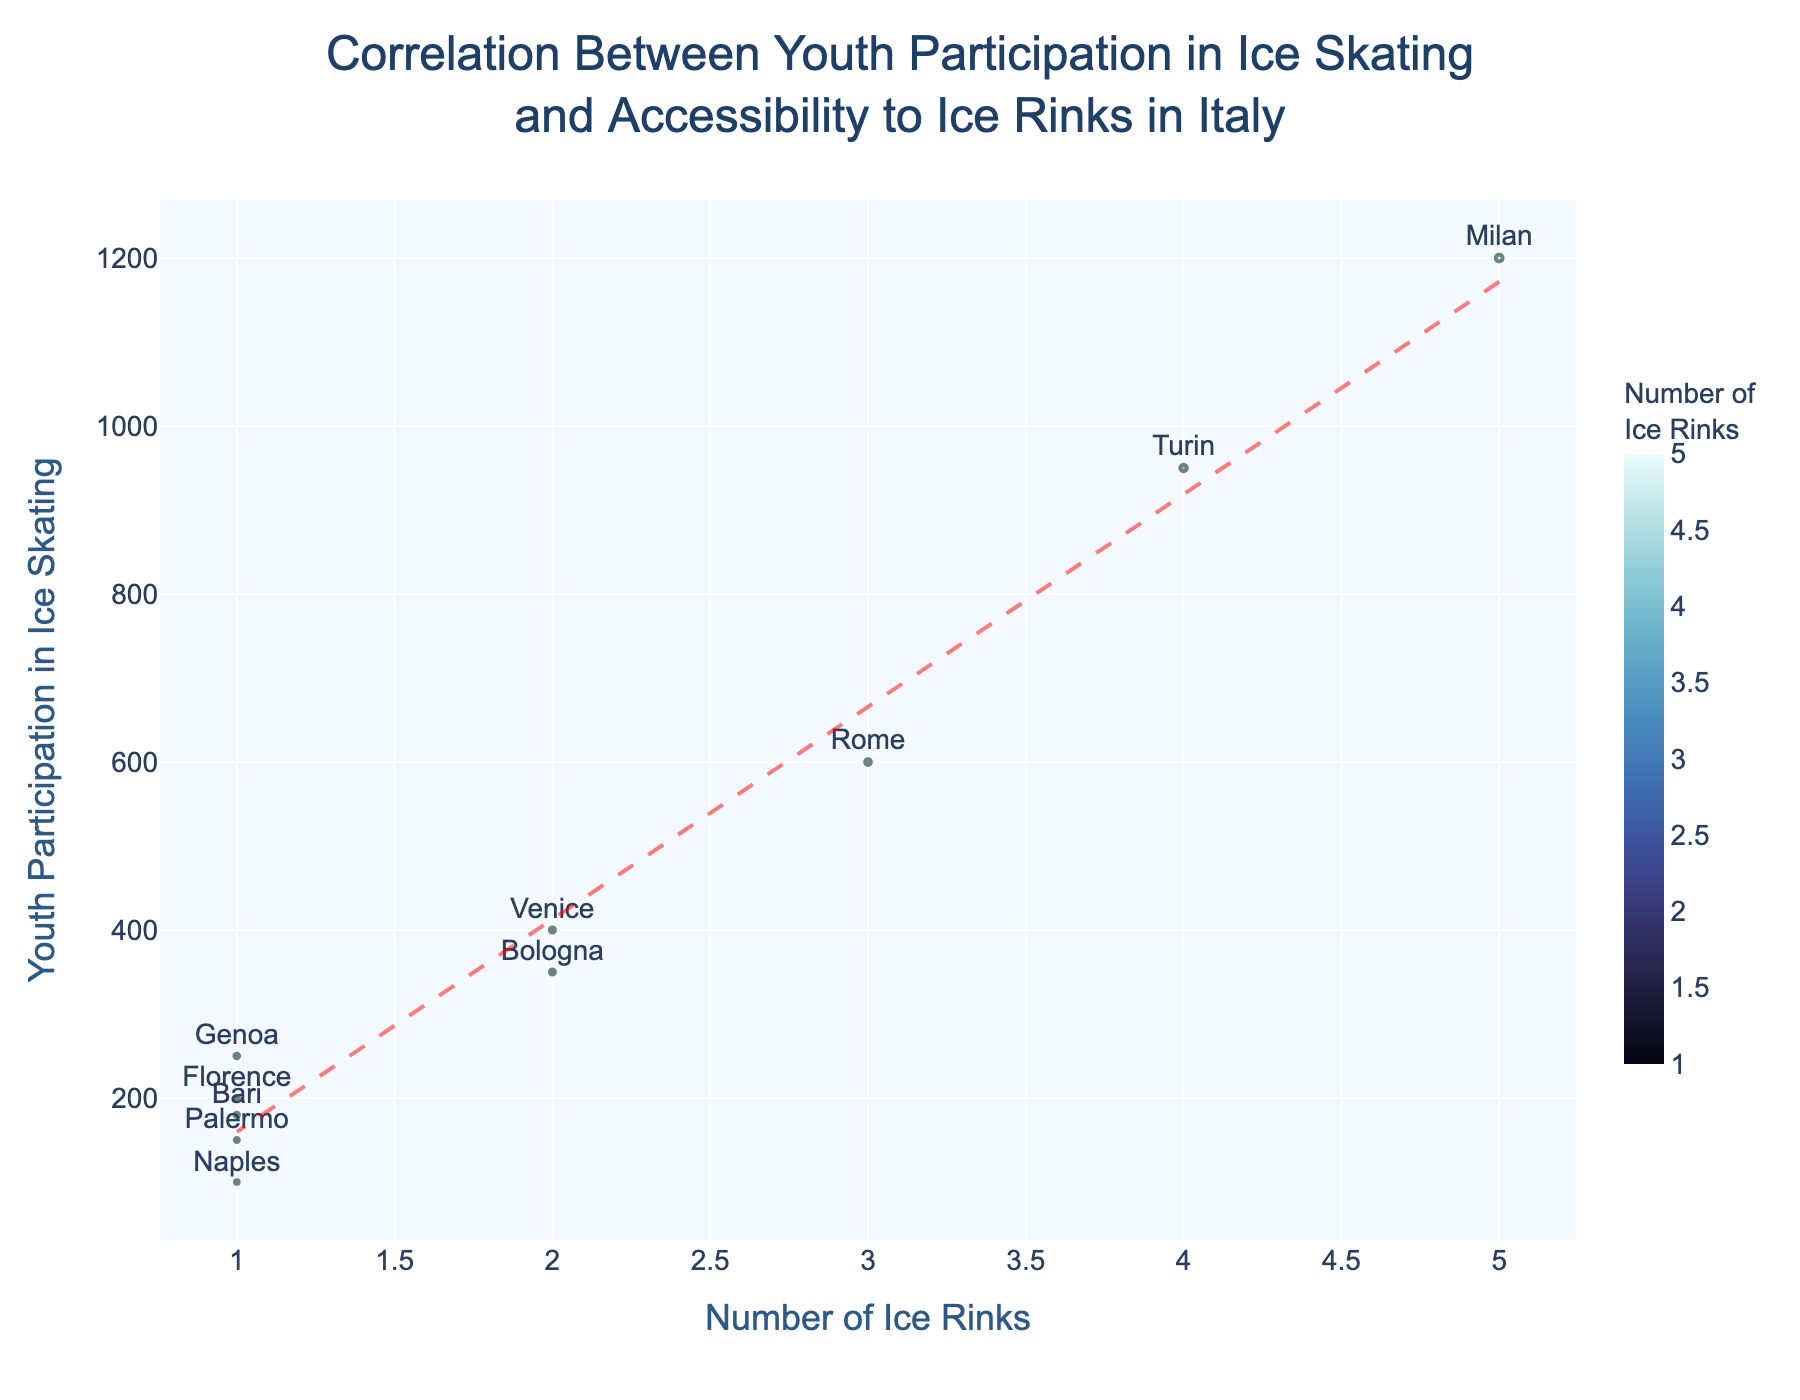What's the title of the figure? The title of the figure is located at the top center and provides context on what the figure is about. It reads "Correlation Between Youth Participation in Ice Skating and Accessibility to Ice Rinks in Italy".
Answer: Correlation Between Youth Participation in Ice Skating and Accessibility to Ice Rinks in Italy How many cities are represented in the plot? Each data point in the plot corresponds to a city, and by counting these points (or using the hover data feature), it's evident there are 10 cities represented.
Answer: 10 Which city has the highest youth participation in ice skating? By looking for the data point with the highest y-axis value, we see that Milan, with 1200 participants, has the highest youth participation.
Answer: Milan Which city has the lowest number of ice rinks? The city with the lowest x-axis value, which corresponds to the number of ice rinks, can be identified as Bari, Palermo, Naples, or Genoa, each having only 1 ice rink.
Answer: Bari, Palermo, Naples, Genoa What is the trend line's role in this plot? The trend line helps in visualizing the overall direction of the correlation between the number of ice rinks and youth participation, showing whether an increasing number of rinks correlates with higher participation.
Answer: Visualizes correlation direction Compare the youth participation in ice skating in Rome and Venice. Which city has higher participation? By comparing the y-values for Rome and Venice, we see that Rome has a higher youth participation (600) compared to Venice (400).
Answer: Rome What is the color scale used for the data points based on? The color scale for the data points ranges with respect to the number of ice rinks, helping to distinguish cities with different rink counts visually.
Answer: Number of Ice Rinks What is the relationship shown between the number of ice rinks and youth participation in ice skating? The trend line indicates a positive relationship, suggesting that as the number of ice rinks increases, youth participation in ice skating generally tends to increase.
Answer: Positive relationship What is the average number of ice rinks across the 10 cities? Sum up the number of ice rinks (5+4+3+2+2+1+1+1+1+1 = 21) and divide by the number of cities (10), giving an average of 2.1 ice rinks.
Answer: 2.1 Is there an outlier city in terms of youth participation in ice skating? By observing the plot, Milan stands out as an outlier with significantly higher youth participation (1200) compared to other cities.
Answer: Milan 